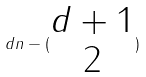Convert formula to latex. <formula><loc_0><loc_0><loc_500><loc_500>d n - ( \begin{matrix} d + 1 \\ 2 \end{matrix} )</formula> 